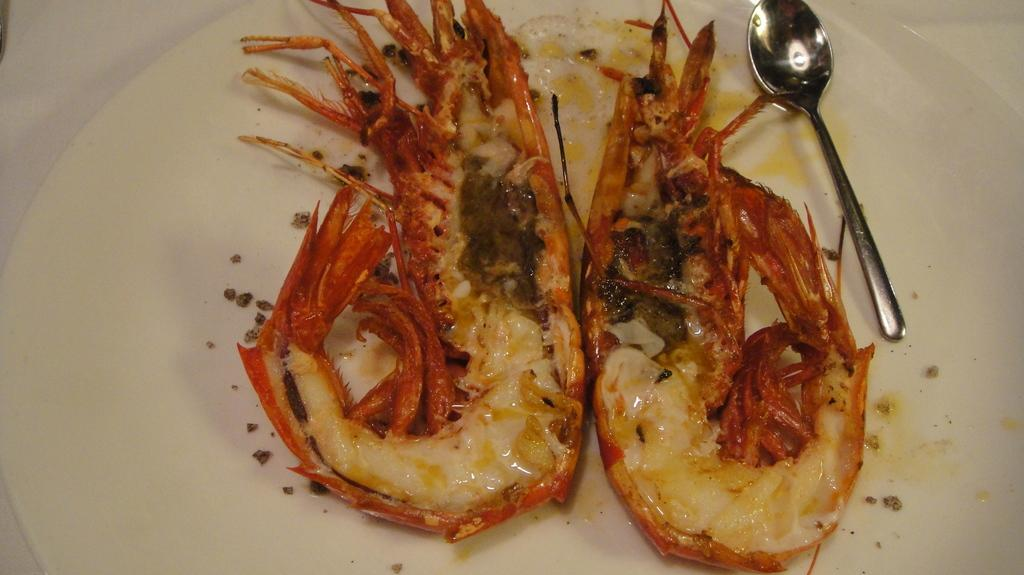What color is the plate in the image? The plate in the image is white. What utensil is placed on the plate? There is a spoon on the plate. What is on the plate besides the spoon? There is food on the plate. Can you see any quicksand in the image? No, there is no quicksand present in the image. What type of birds are flying over the plate in the image? There are no birds present in the image. 